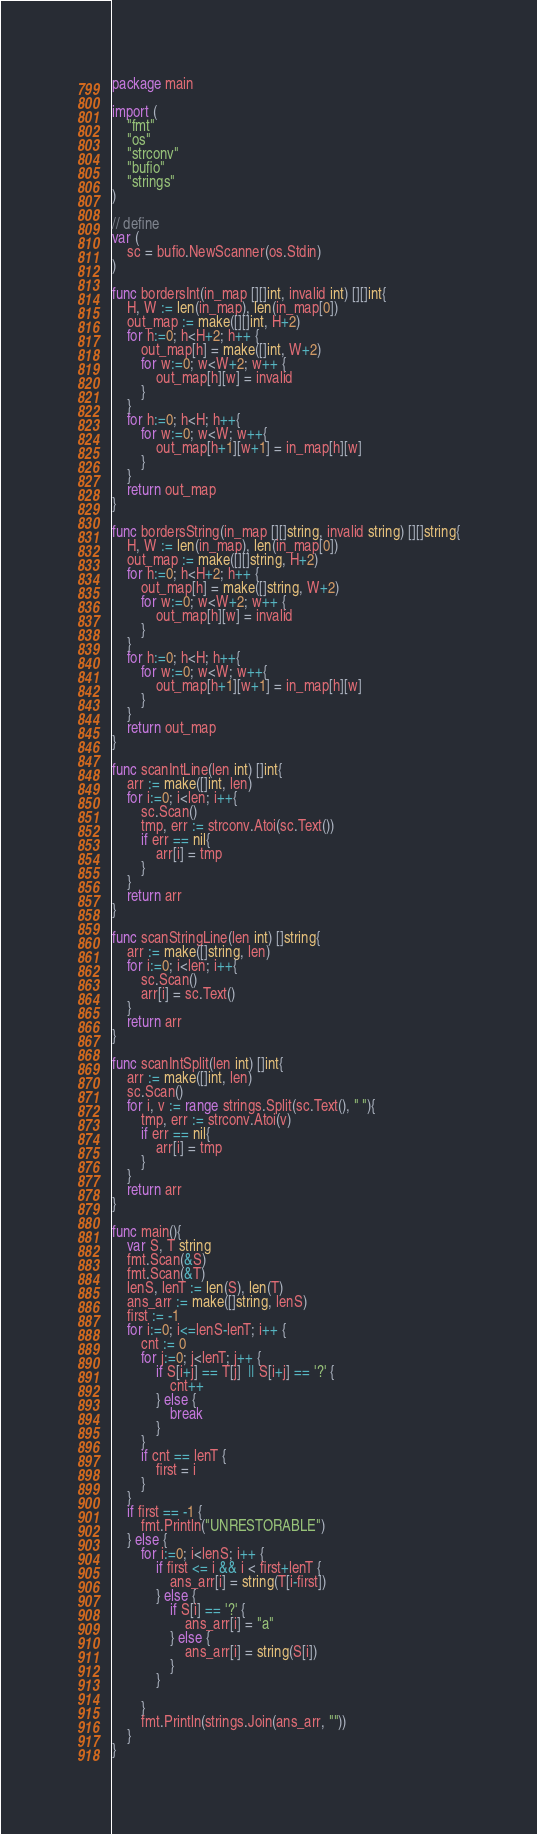<code> <loc_0><loc_0><loc_500><loc_500><_Go_>package main

import (
	"fmt"
	"os"
	"strconv"
	"bufio"
	"strings"
)

// define
var (
	sc = bufio.NewScanner(os.Stdin)
)

func bordersInt(in_map [][]int, invalid int) [][]int{
	H, W := len(in_map), len(in_map[0])
	out_map := make([][]int, H+2)
	for h:=0; h<H+2; h++ {
		out_map[h] = make([]int, W+2)
		for w:=0; w<W+2; w++ {
			out_map[h][w] = invalid
		}
	}
	for h:=0; h<H; h++{
		for w:=0; w<W; w++{
			out_map[h+1][w+1] = in_map[h][w] 
		}
	}
	return out_map
}

func bordersString(in_map [][]string, invalid string) [][]string{
	H, W := len(in_map), len(in_map[0])
	out_map := make([][]string, H+2)
	for h:=0; h<H+2; h++ {
		out_map[h] = make([]string, W+2)
		for w:=0; w<W+2; w++ {
			out_map[h][w] = invalid
		}
	}
	for h:=0; h<H; h++{
		for w:=0; w<W; w++{
			out_map[h+1][w+1] = in_map[h][w] 
		}
	}
	return out_map
}

func scanIntLine(len int) []int{
	arr := make([]int, len)
	for i:=0; i<len; i++{
		sc.Scan()
		tmp, err := strconv.Atoi(sc.Text())
		if err == nil{
			arr[i] = tmp
		}
	}
	return arr
}

func scanStringLine(len int) []string{
	arr := make([]string, len)
	for i:=0; i<len; i++{
		sc.Scan()
		arr[i] = sc.Text()
	}
	return arr
}

func scanIntSplit(len int) []int{
	arr := make([]int, len)
	sc.Scan()
	for i, v := range strings.Split(sc.Text(), " "){
		tmp, err := strconv.Atoi(v)
		if err == nil{
			arr[i] = tmp
		}
	}
	return arr
}

func main(){
	var S, T string
	fmt.Scan(&S)
	fmt.Scan(&T)
	lenS, lenT := len(S), len(T)
	ans_arr := make([]string, lenS)
	first := -1
	for i:=0; i<=lenS-lenT; i++ {
		cnt := 0
		for j:=0; j<lenT; j++ {
			if S[i+j] == T[j]  || S[i+j] == '?' {
				cnt++
			} else {
				break
			}
		}
		if cnt == lenT {
			first = i
		}
	}
	if first == -1 {
		fmt.Println("UNRESTORABLE")
	} else {
		for i:=0; i<lenS; i++ {
			if first <= i && i < first+lenT {
				ans_arr[i] = string(T[i-first])
			} else {
				if S[i] == '?' {
					ans_arr[i] = "a"
				} else {
					ans_arr[i] = string(S[i])	
				}
			}
			
		}
		fmt.Println(strings.Join(ans_arr, ""))
	}
}</code> 